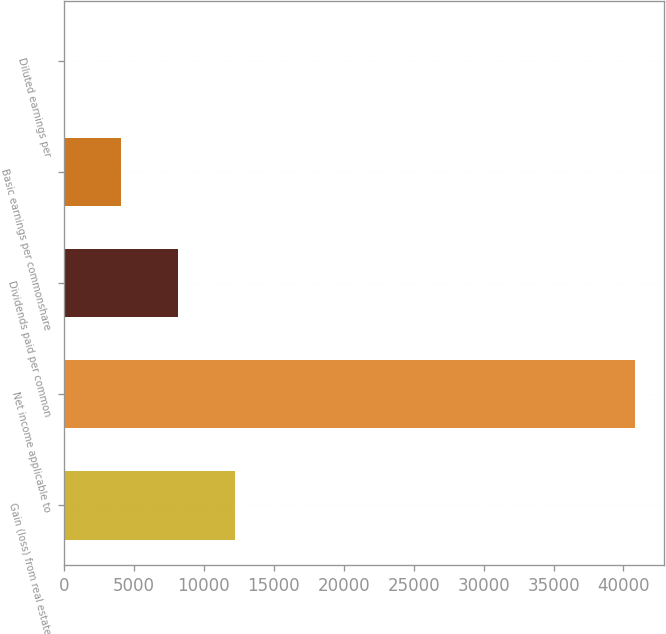<chart> <loc_0><loc_0><loc_500><loc_500><bar_chart><fcel>Gain (loss) from real estate<fcel>Net income applicable to<fcel>Dividends paid per common<fcel>Basic earnings per commonshare<fcel>Diluted earnings per<nl><fcel>12254.6<fcel>40848<fcel>8169.84<fcel>4085.07<fcel>0.3<nl></chart> 